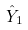<formula> <loc_0><loc_0><loc_500><loc_500>\hat { Y } _ { 1 }</formula> 